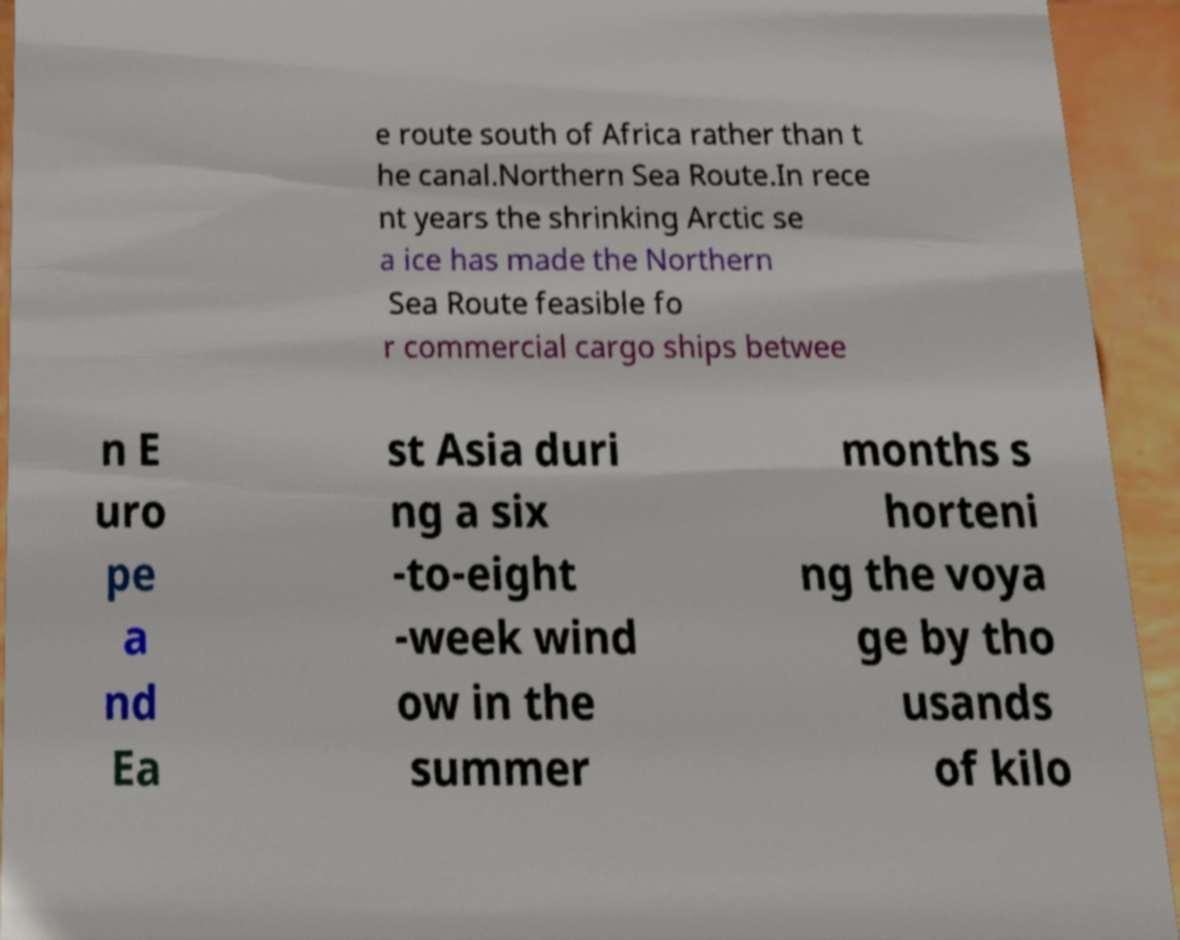Can you accurately transcribe the text from the provided image for me? e route south of Africa rather than t he canal.Northern Sea Route.In rece nt years the shrinking Arctic se a ice has made the Northern Sea Route feasible fo r commercial cargo ships betwee n E uro pe a nd Ea st Asia duri ng a six -to-eight -week wind ow in the summer months s horteni ng the voya ge by tho usands of kilo 